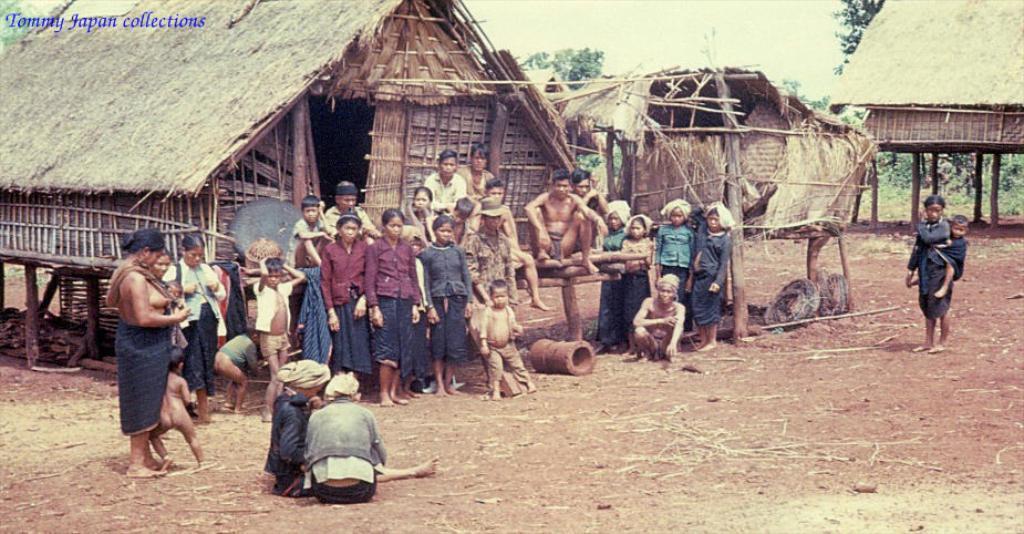Describe this image in one or two sentences. In this picture I can see a group of people at the center, behind them there are huts. In the background I can see few trees, in the top left hand side there is the text. 